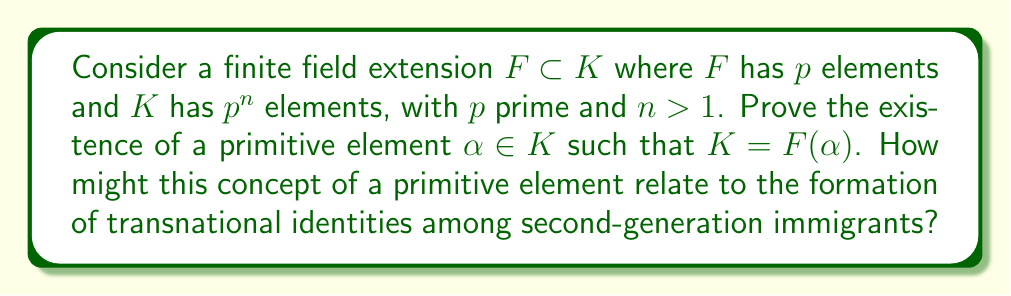Provide a solution to this math problem. 1. First, recall that $K$ is a vector space over $F$ with dimension $n$.

2. Let $\{1, \alpha_1, \alpha_2, ..., \alpha_{n-1}\}$ be a basis for $K$ over $F$.

3. Consider the set $S = \{\sum_{i=0}^{n-1} c_i \alpha_i : c_i \in F\}$. This set has $p^n$ elements, which is equal to the number of elements in $K$.

4. Therefore, $S = K$.

5. Now, let's construct a primitive element. Define:

   $$\alpha = \alpha_1 + t\alpha_2 + t^2\alpha_3 + ... + t^{n-2}\alpha_{n-1}$$

   where $t$ is an indeterminate.

6. For any $f \in F[t]$, $f(\alpha)$ is a linear combination of $1, \alpha_1, ..., \alpha_{n-1}$ over $F$.

7. The minimal polynomial of $\alpha$ over $F$ has degree at most $n$.

8. If the degree were less than $n$, there would be a non-zero polynomial $g \in F[t]$ of degree less than $n$ such that $g(\alpha) = 0$.

9. This would imply a linear dependence among $1, \alpha_1, ..., \alpha_{n-1}$, contradicting the fact that they form a basis.

10. Therefore, the minimal polynomial of $\alpha$ has degree $n$, and $[F(\alpha):F] = n = [K:F]$.

11. Thus, $F(\alpha) = K$, proving that $\alpha$ is a primitive element.

Relating to transnational identities:
The primitive element $\alpha$ generates the entire field extension $K$, just as a second-generation immigrant's identity might be generated from a combination of cultural elements from both their heritage and adopted countries. The uniqueness of $\alpha$ could represent the unique blend of cultural influences that form an individual's transnational identity.
Answer: A primitive element $\alpha$ exists and $K = F(\alpha)$. 